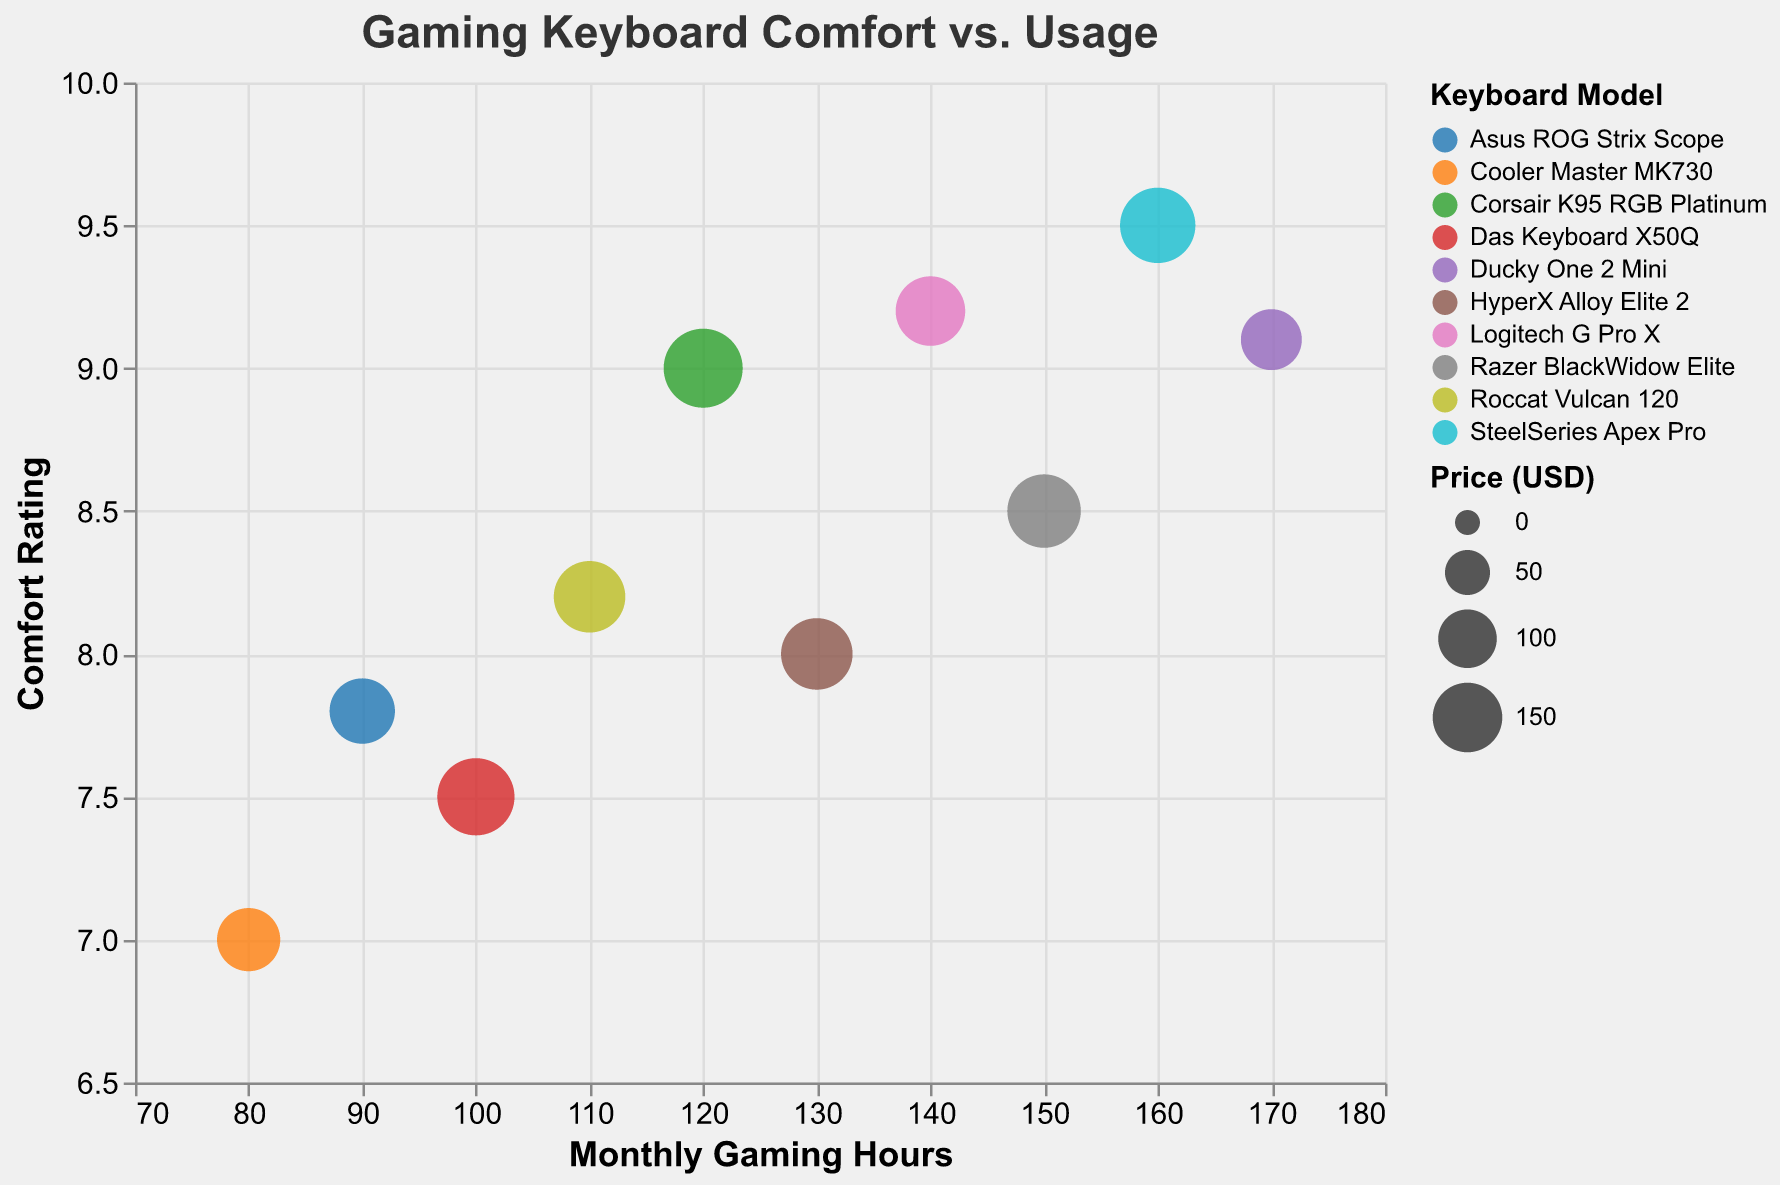What's the title of the chart? The title of the chart is located at the top and states the main purpose or subject of the visual. Here, it says "Gaming Keyboard Comfort vs. Usage."
Answer: Gaming Keyboard Comfort vs. Usage How many keyboard models are compared in the figure? The number of data points, each representing a different keyboard model, is counted. In the legend, multiple colors indicate distinct models, resulting in 10 different keyboard models.
Answer: 10 Which keyboard model shows the highest comfort rating? By identifying the bubble on the chart with the highest position on the y-axis labeled "Comfort Rating," the SteelSeries Apex Pro has a comfort rating of 9.5, which is higher than any other model.
Answer: SteelSeries Apex Pro What is the price of the keyboard model with the lowest monthly gaming hours? Find the bubble furthest to the left on the x-axis labeled "Monthly Gaming Hours," which corresponds to the Cooler Master MK730. The tooltip or size of the bubble indicates that this model costs $119.99.
Answer: $119.99 What is the average comfort rating of the Corsair K95 RGB Platinum and HyperX Alloy Elite 2? Add the comfort ratings of Corsair K95 RGB Platinum (9) and HyperX Alloy Elite 2 (8), and then divide by 2 to get the average. Thus, (9 + 8) / 2 = 8.5.
Answer: 8.5 Which keyboard is more expensive: Razer BlackWidow Elite or Das Keyboard X50Q? Compare the sizes of the bubbles (sizes reflect price) corresponding to Razer BlackWidow Elite and Das Keyboard X50Q. The Das Keyboard X50Q, with a price of $189.99, is more expensive than Razer BlackWidow Elite at $169.99.
Answer: Das Keyboard X50Q What is the difference in monthly gaming hours between the Logitech G Pro X and the Ducky One 2 Mini? Subtract the monthly gaming hours of the Logitech G Pro X (140) from the Ducky One 2 Mini (170): 170 - 140 = 30.
Answer: 30 hours Which keyboard model has the lowest comfort rating and what is its monthly gaming hours? Identify the bubble located at the bottom of the y-axis for "Comfort Rating," representing Cooler Master MK730 with a comfort rating of 7 and monthly gaming hours of 80.
Answer: Cooler Master MK730 - 80 hours How does the price of the most comfortable keyboard compare to the price of the least comfortable one? Compare the prices of SteelSeries Apex Pro ($179.99) and Cooler Master MK730 ($119.99). The SteelSeries Apex Pro is more expensive by $60: $179.99 - $119.99.
Answer: $60 more What's the average monthly gaming hours for keyboards with a comfort rating above 9? Identify the models with a comfort rating above 9 (SteelSeries Apex Pro, Ducky One 2 Mini, and Logitech G Pro X: 160, 170, and 140 hours respectively). Add these hours and divide by 3: (160 + 170 + 140) / 3 = 156.67 hours.
Answer: 156.67 hours 